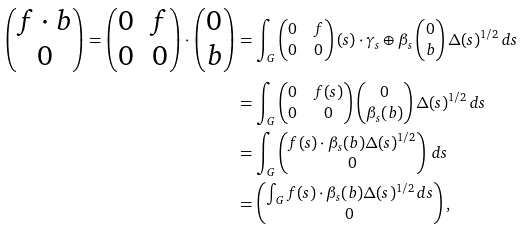Convert formula to latex. <formula><loc_0><loc_0><loc_500><loc_500>\begin{pmatrix} f \cdot b \\ 0 \end{pmatrix} = \begin{pmatrix} 0 & f \\ 0 & 0 \end{pmatrix} \cdot \begin{pmatrix} 0 \\ b \end{pmatrix} & = \int _ { G } \begin{pmatrix} 0 & f \\ 0 & 0 \end{pmatrix} ( s ) \cdot \gamma _ { s } \oplus \beta _ { s } \begin{pmatrix} 0 \\ b \end{pmatrix} \Delta ( s ) ^ { 1 / 2 } \, d s \\ & = \int _ { G } \begin{pmatrix} 0 & f ( s ) \\ 0 & 0 \end{pmatrix} \begin{pmatrix} 0 \\ \beta _ { s } ( b ) \end{pmatrix} \Delta ( s ) ^ { 1 / 2 } \, d s \\ & = \int _ { G } \begin{pmatrix} f ( s ) \cdot \beta _ { s } ( b ) \Delta ( s ) ^ { 1 / 2 } \\ 0 \end{pmatrix} \, d s \\ & = \begin{pmatrix} \int _ { G } f ( s ) \cdot \beta _ { s } ( b ) \Delta ( s ) ^ { 1 / 2 } \, d s \\ 0 \end{pmatrix} ,</formula> 